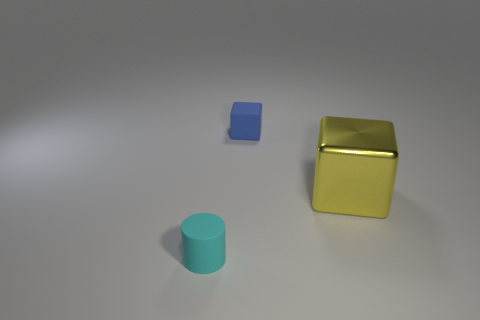Subtract all purple cubes. Subtract all green cylinders. How many cubes are left? 2 Add 2 yellow spheres. How many objects exist? 5 Subtract all cylinders. How many objects are left? 2 Add 3 tiny cyan matte cylinders. How many tiny cyan matte cylinders are left? 4 Add 3 brown rubber cylinders. How many brown rubber cylinders exist? 3 Subtract 1 cyan cylinders. How many objects are left? 2 Subtract all large metal things. Subtract all small things. How many objects are left? 0 